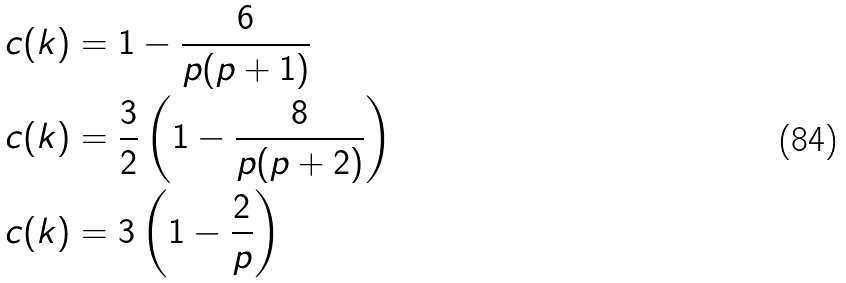<formula> <loc_0><loc_0><loc_500><loc_500>c ( k ) & = 1 - \frac { 6 } { p ( p + 1 ) } \\ c ( k ) & = \frac { 3 } { 2 } \left ( 1 - \frac { 8 } { p ( p + 2 ) } \right ) \\ c ( k ) & = 3 \left ( 1 - \frac { 2 } { p } \right )</formula> 